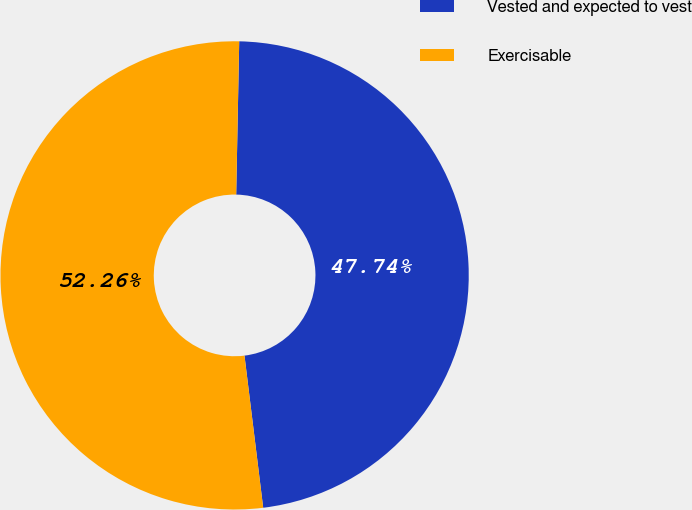<chart> <loc_0><loc_0><loc_500><loc_500><pie_chart><fcel>Vested and expected to vest<fcel>Exercisable<nl><fcel>47.74%<fcel>52.26%<nl></chart> 